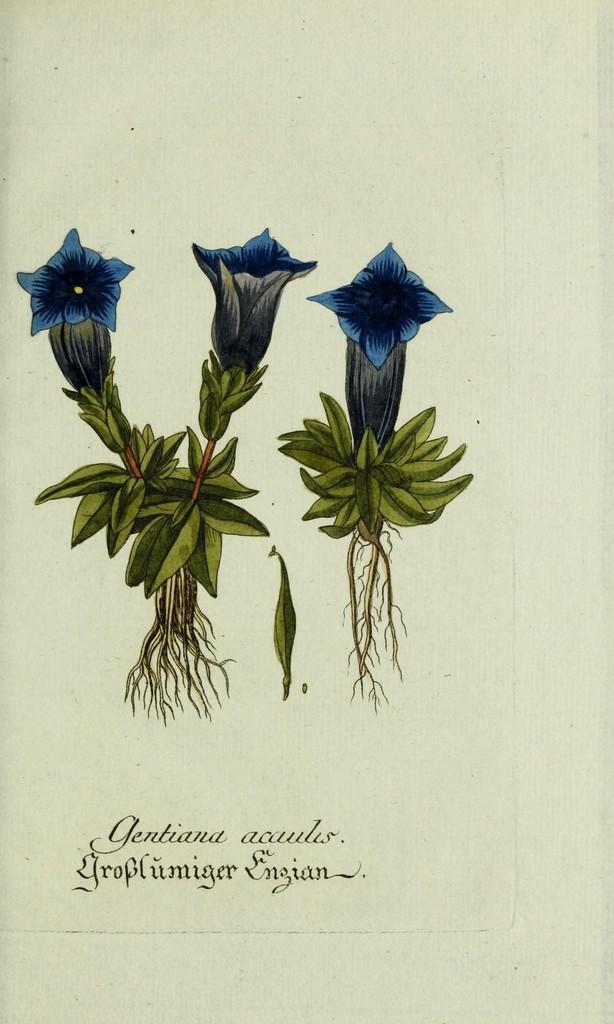In one or two sentences, can you explain what this image depicts? In this picture we can see art of flowers and plants, and also we can see some text. 